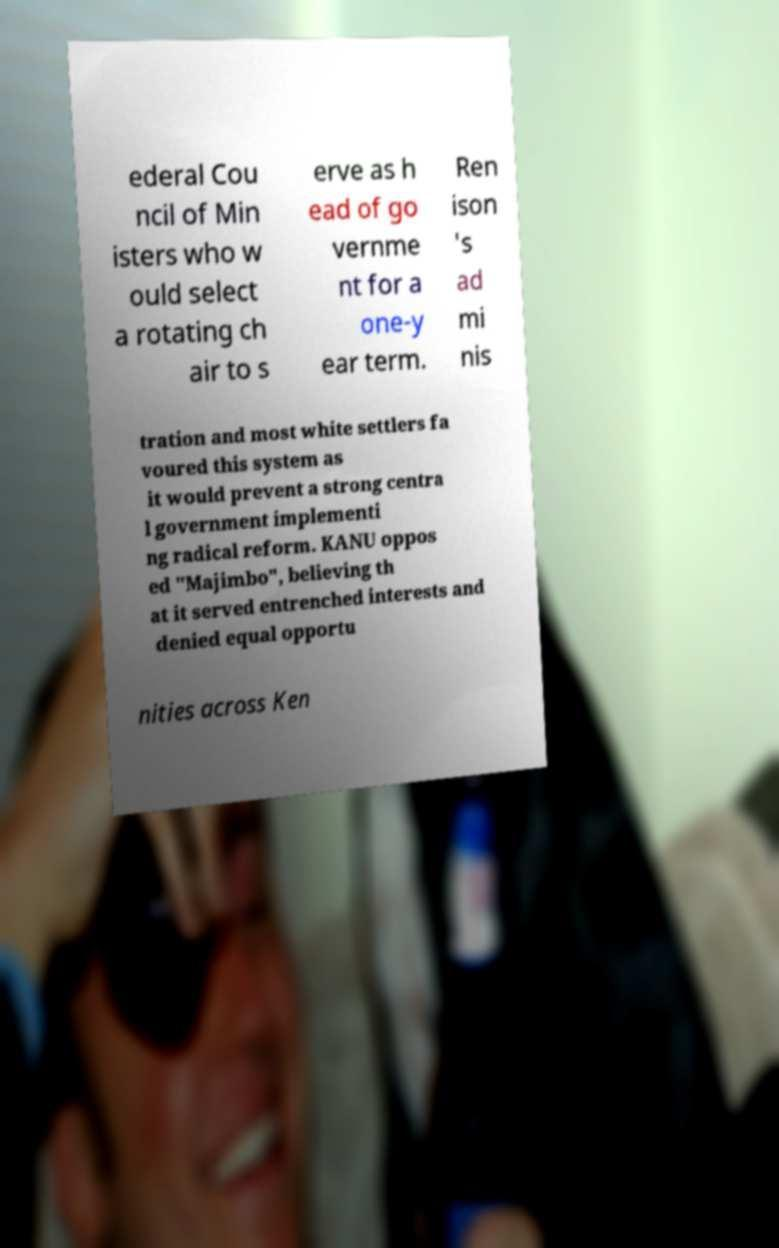Can you read and provide the text displayed in the image?This photo seems to have some interesting text. Can you extract and type it out for me? ederal Cou ncil of Min isters who w ould select a rotating ch air to s erve as h ead of go vernme nt for a one-y ear term. Ren ison 's ad mi nis tration and most white settlers fa voured this system as it would prevent a strong centra l government implementi ng radical reform. KANU oppos ed "Majimbo", believing th at it served entrenched interests and denied equal opportu nities across Ken 